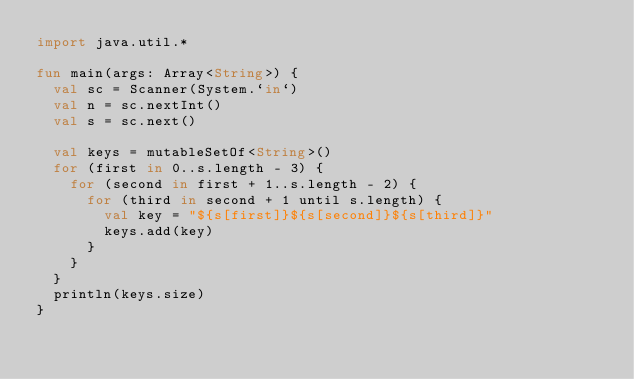Convert code to text. <code><loc_0><loc_0><loc_500><loc_500><_Kotlin_>import java.util.*

fun main(args: Array<String>) {
  val sc = Scanner(System.`in`)
  val n = sc.nextInt()
  val s = sc.next()

  val keys = mutableSetOf<String>()
  for (first in 0..s.length - 3) {
    for (second in first + 1..s.length - 2) {
      for (third in second + 1 until s.length) {
        val key = "${s[first]}${s[second]}${s[third]}"
        keys.add(key)
      }
    }
  }
  println(keys.size)
}</code> 